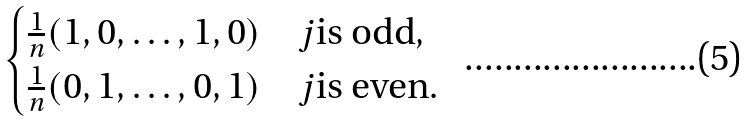<formula> <loc_0><loc_0><loc_500><loc_500>\begin{cases} { \frac { 1 } { n } } ( 1 , 0 , \dots , 1 , 0 ) & j \text {is odd} , \\ { \frac { 1 } { n } } ( 0 , 1 , \dots , 0 , 1 ) & j \text {is even} . \end{cases}</formula> 